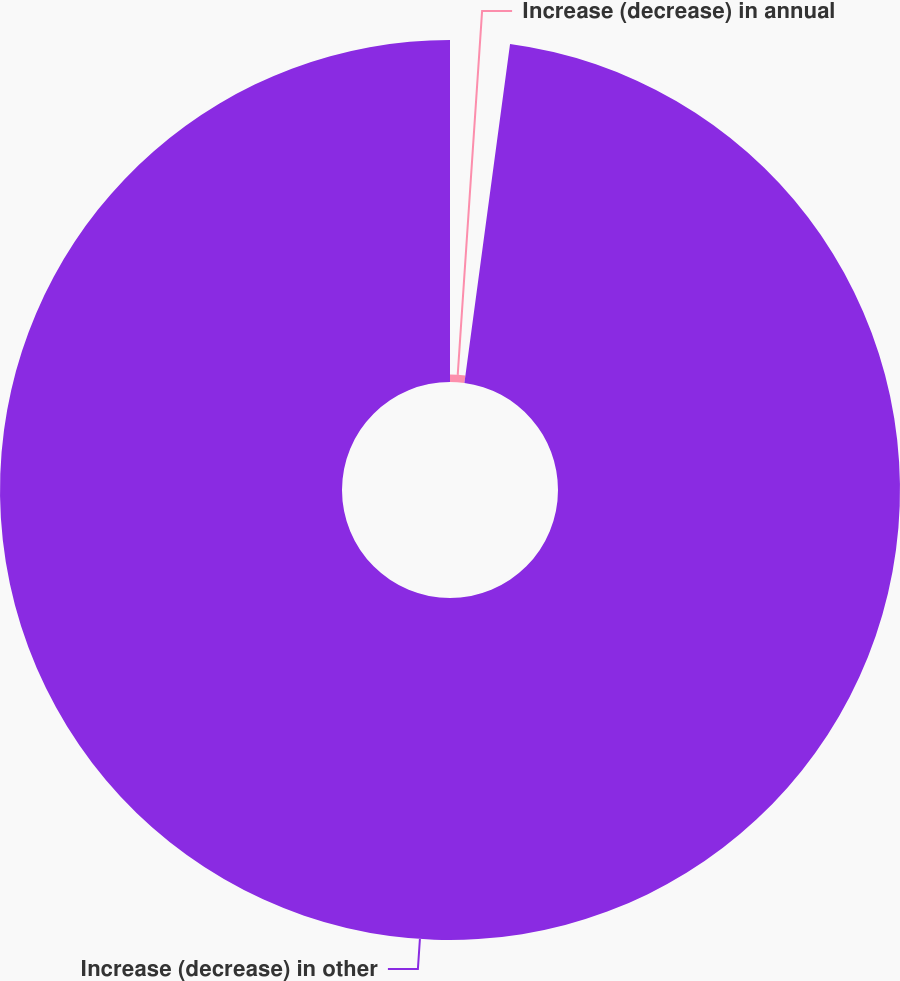Convert chart. <chart><loc_0><loc_0><loc_500><loc_500><pie_chart><fcel>Increase (decrease) in annual<fcel>Increase (decrease) in other<nl><fcel>2.13%<fcel>97.87%<nl></chart> 